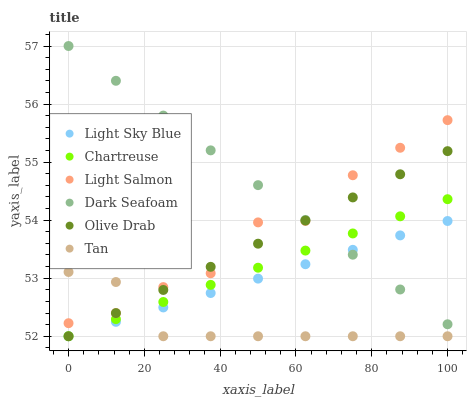Does Tan have the minimum area under the curve?
Answer yes or no. Yes. Does Dark Seafoam have the maximum area under the curve?
Answer yes or no. Yes. Does Chartreuse have the minimum area under the curve?
Answer yes or no. No. Does Chartreuse have the maximum area under the curve?
Answer yes or no. No. Is Dark Seafoam the smoothest?
Answer yes or no. Yes. Is Light Salmon the roughest?
Answer yes or no. Yes. Is Chartreuse the smoothest?
Answer yes or no. No. Is Chartreuse the roughest?
Answer yes or no. No. Does Chartreuse have the lowest value?
Answer yes or no. Yes. Does Dark Seafoam have the lowest value?
Answer yes or no. No. Does Dark Seafoam have the highest value?
Answer yes or no. Yes. Does Chartreuse have the highest value?
Answer yes or no. No. Is Chartreuse less than Light Salmon?
Answer yes or no. Yes. Is Light Salmon greater than Light Sky Blue?
Answer yes or no. Yes. Does Tan intersect Light Salmon?
Answer yes or no. Yes. Is Tan less than Light Salmon?
Answer yes or no. No. Is Tan greater than Light Salmon?
Answer yes or no. No. Does Chartreuse intersect Light Salmon?
Answer yes or no. No. 